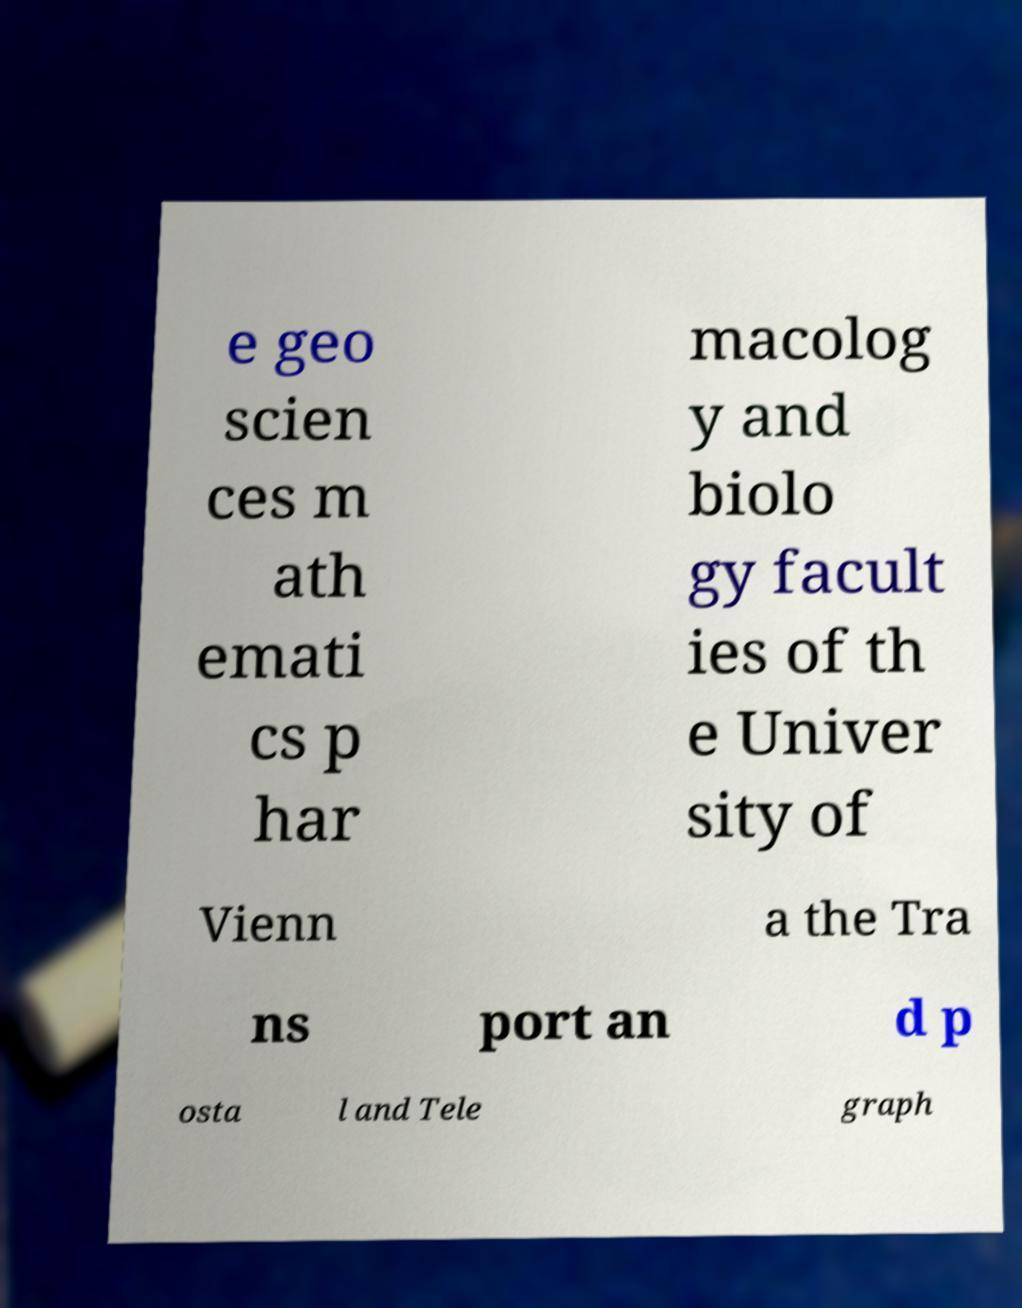For documentation purposes, I need the text within this image transcribed. Could you provide that? e geo scien ces m ath emati cs p har macolog y and biolo gy facult ies of th e Univer sity of Vienn a the Tra ns port an d p osta l and Tele graph 